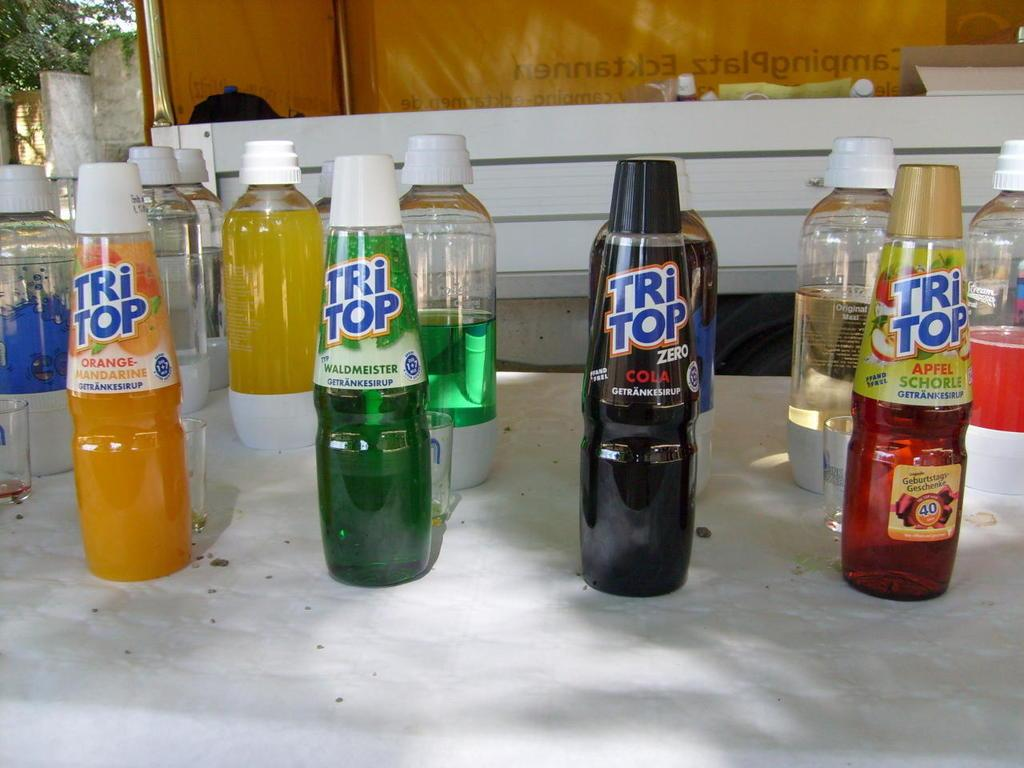Provide a one-sentence caption for the provided image. Four bottles of various flavors of Tri Top displayed on a counter. 